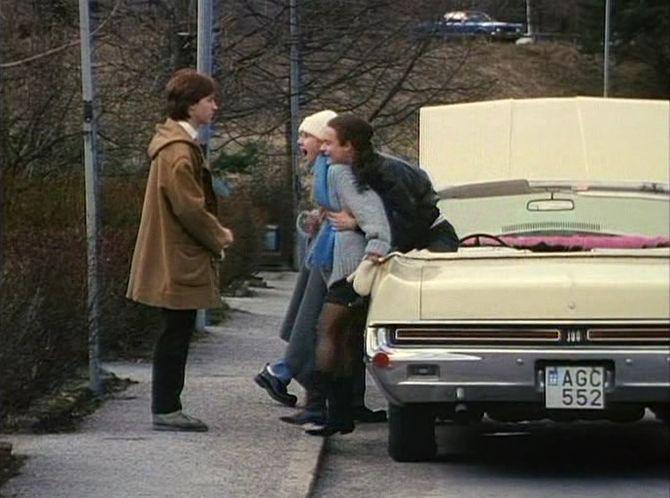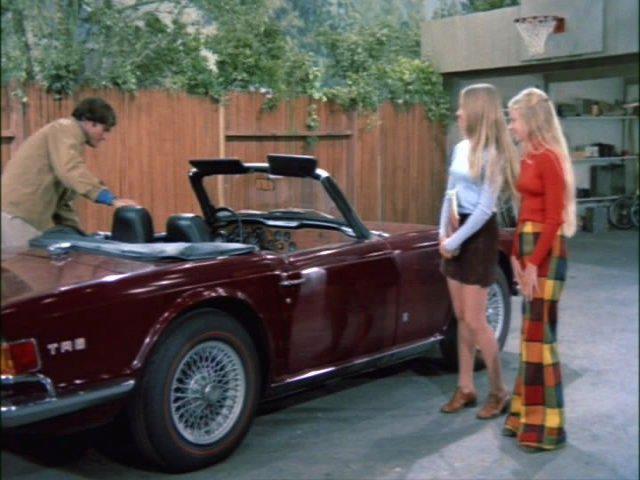The first image is the image on the left, the second image is the image on the right. For the images displayed, is the sentence "in the left image there is a sidewalk to the left of the car" factually correct? Answer yes or no. Yes. 